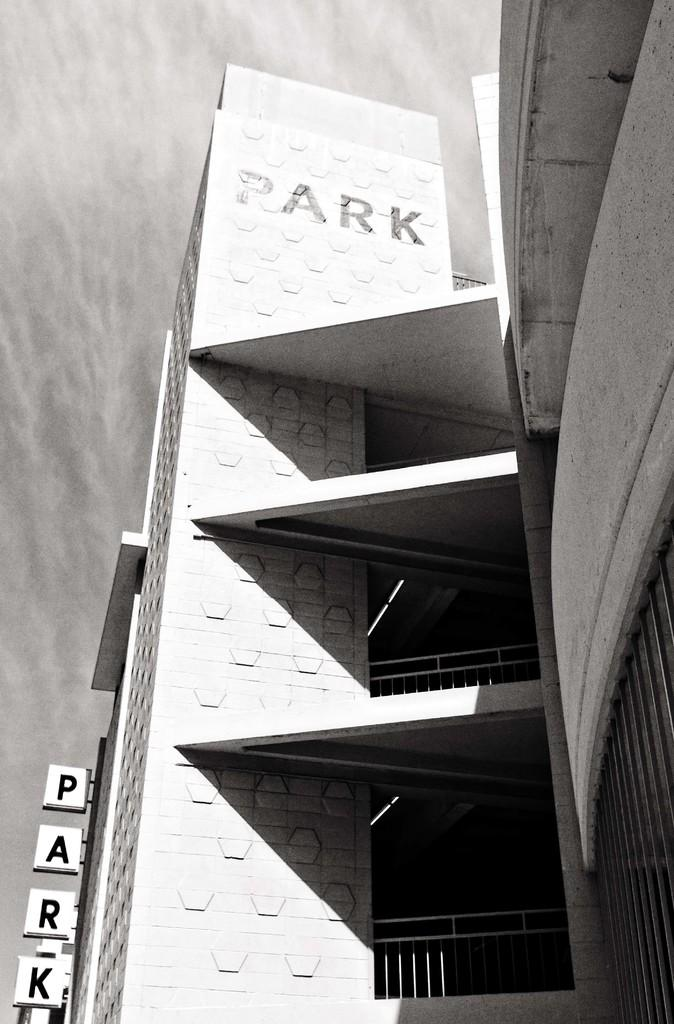What type of picture is in the image? The image contains a black and white picture of a building. What else can be seen in the image besides the building? There is text and a board attached to the building in the image. What is visible in the background of the image? The sky is visible in the background of the image. What type of pie is being served on the roof in the image? There is no roof or pie present in the image; it features a black and white picture of a building with text and a board attached to it. 